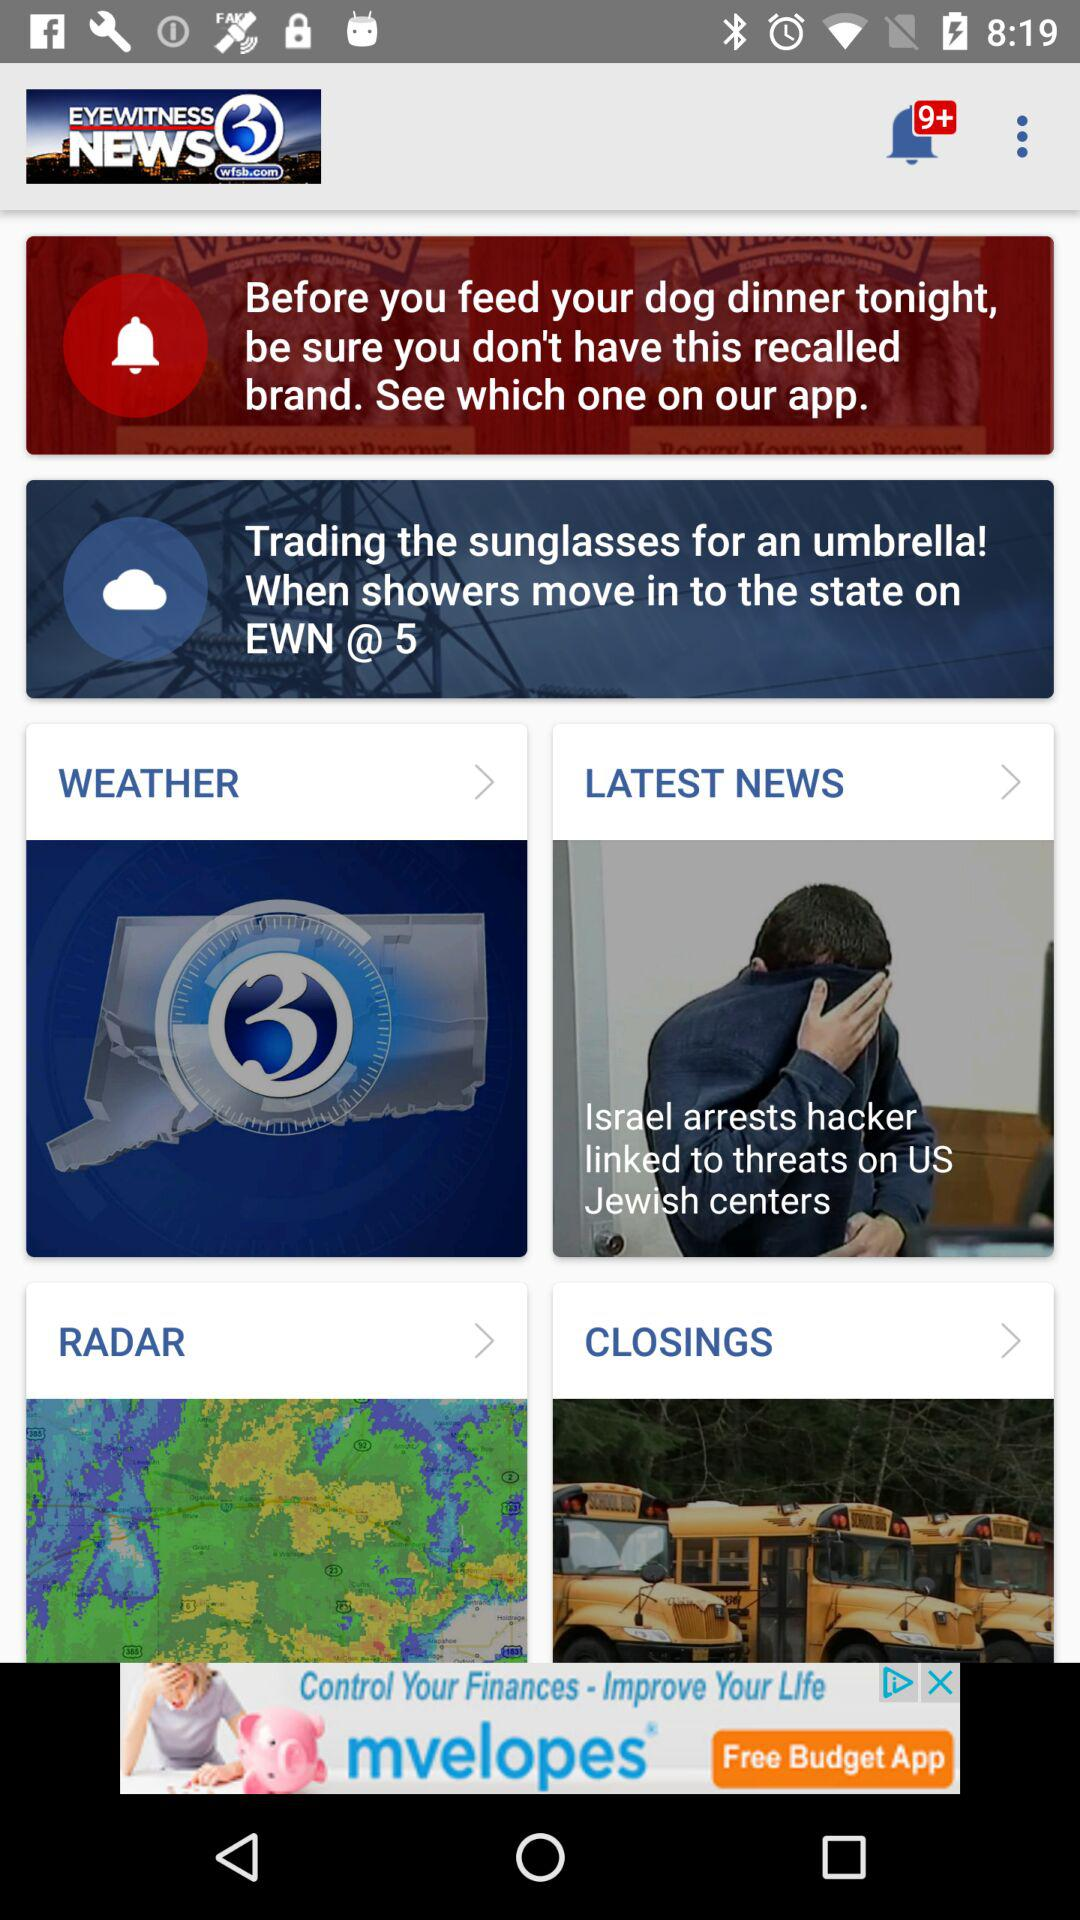What is the name of the application? The name of the application is "Channel 3 Eyewitness News WFSB". 